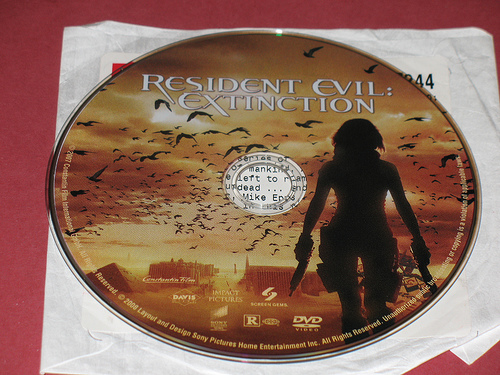<image>
Is the dvd on the envelope? Yes. Looking at the image, I can see the dvd is positioned on top of the envelope, with the envelope providing support. 